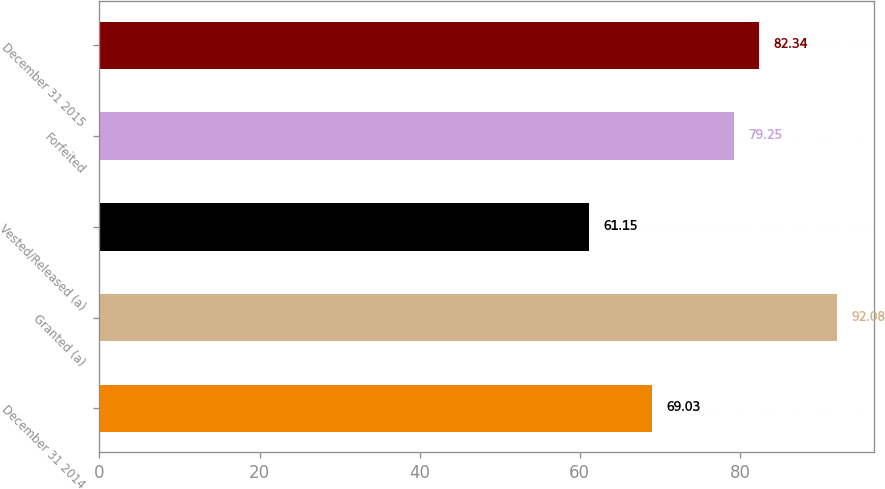Convert chart. <chart><loc_0><loc_0><loc_500><loc_500><bar_chart><fcel>December 31 2014<fcel>Granted (a)<fcel>Vested/Released (a)<fcel>Forfeited<fcel>December 31 2015<nl><fcel>69.03<fcel>92.08<fcel>61.15<fcel>79.25<fcel>82.34<nl></chart> 